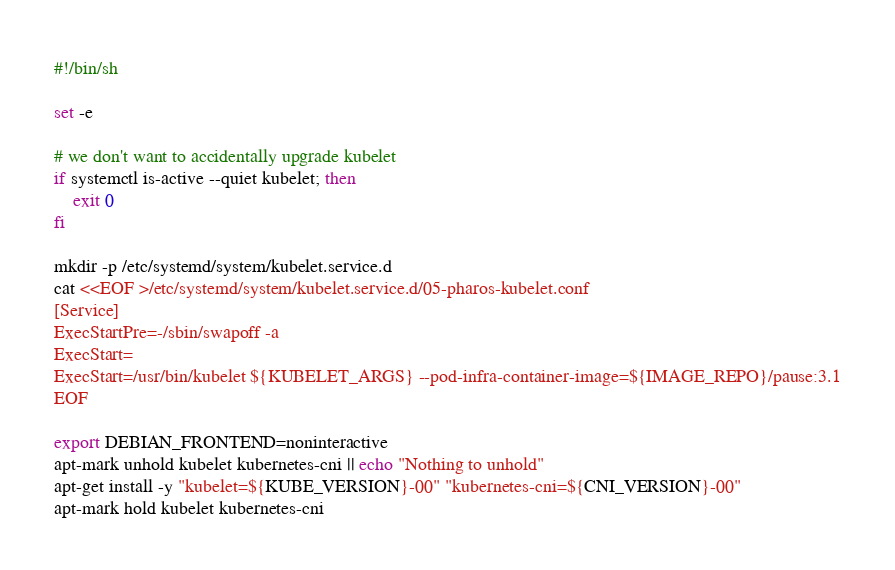Convert code to text. <code><loc_0><loc_0><loc_500><loc_500><_Bash_>#!/bin/sh

set -e

# we don't want to accidentally upgrade kubelet
if systemctl is-active --quiet kubelet; then
    exit 0
fi

mkdir -p /etc/systemd/system/kubelet.service.d
cat <<EOF >/etc/systemd/system/kubelet.service.d/05-pharos-kubelet.conf
[Service]
ExecStartPre=-/sbin/swapoff -a
ExecStart=
ExecStart=/usr/bin/kubelet ${KUBELET_ARGS} --pod-infra-container-image=${IMAGE_REPO}/pause:3.1
EOF

export DEBIAN_FRONTEND=noninteractive
apt-mark unhold kubelet kubernetes-cni || echo "Nothing to unhold"
apt-get install -y "kubelet=${KUBE_VERSION}-00" "kubernetes-cni=${CNI_VERSION}-00"
apt-mark hold kubelet kubernetes-cni
</code> 